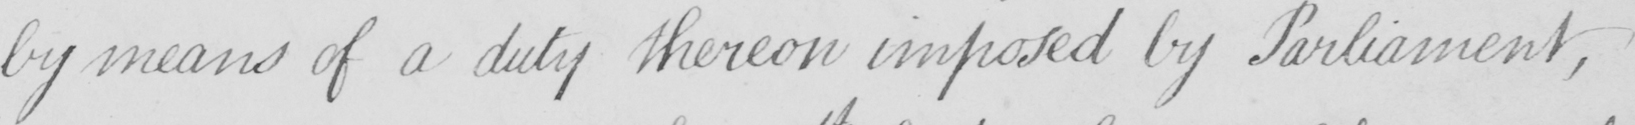Can you tell me what this handwritten text says? by means of a duty thereon imposed by Parliament , 